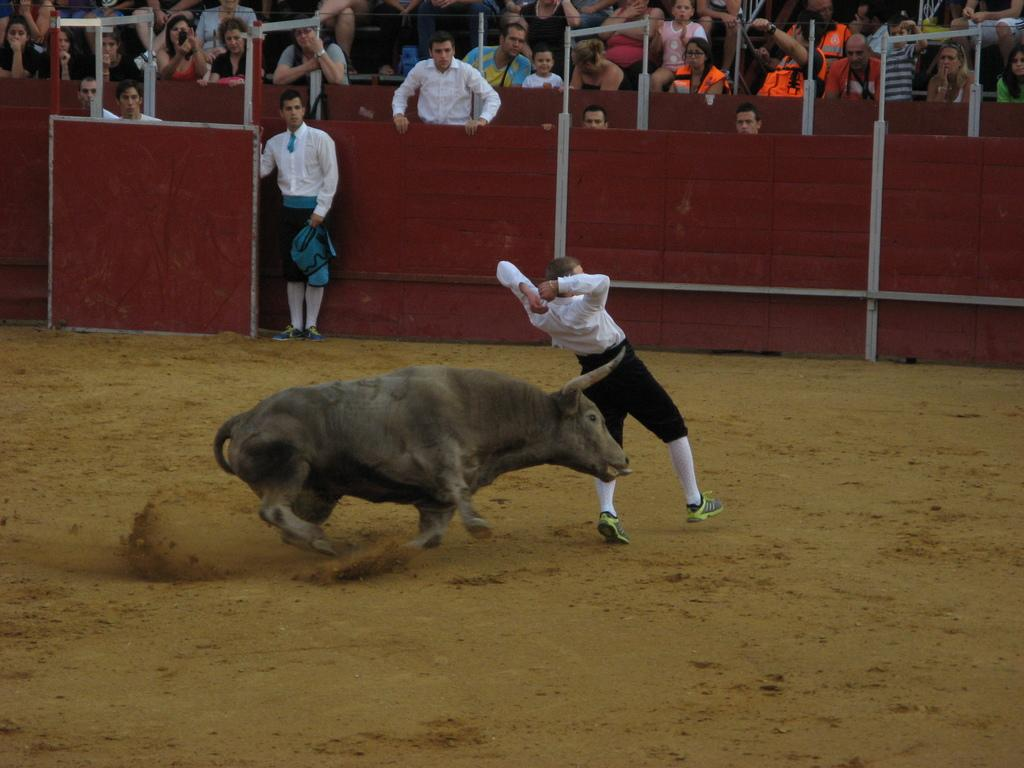What can be seen in the image regarding the people? There are persons wearing clothes in the image. What type of material is used for the walls at the top of the image? There are wooden walls at the top of the image. What is the main subject in the middle of the image? There is an animal in the middle of the image. What shape is the animal in the image? The shape of the animal cannot be determined from the image alone, as it only provides information about the presence of an animal and not its shape or form. 